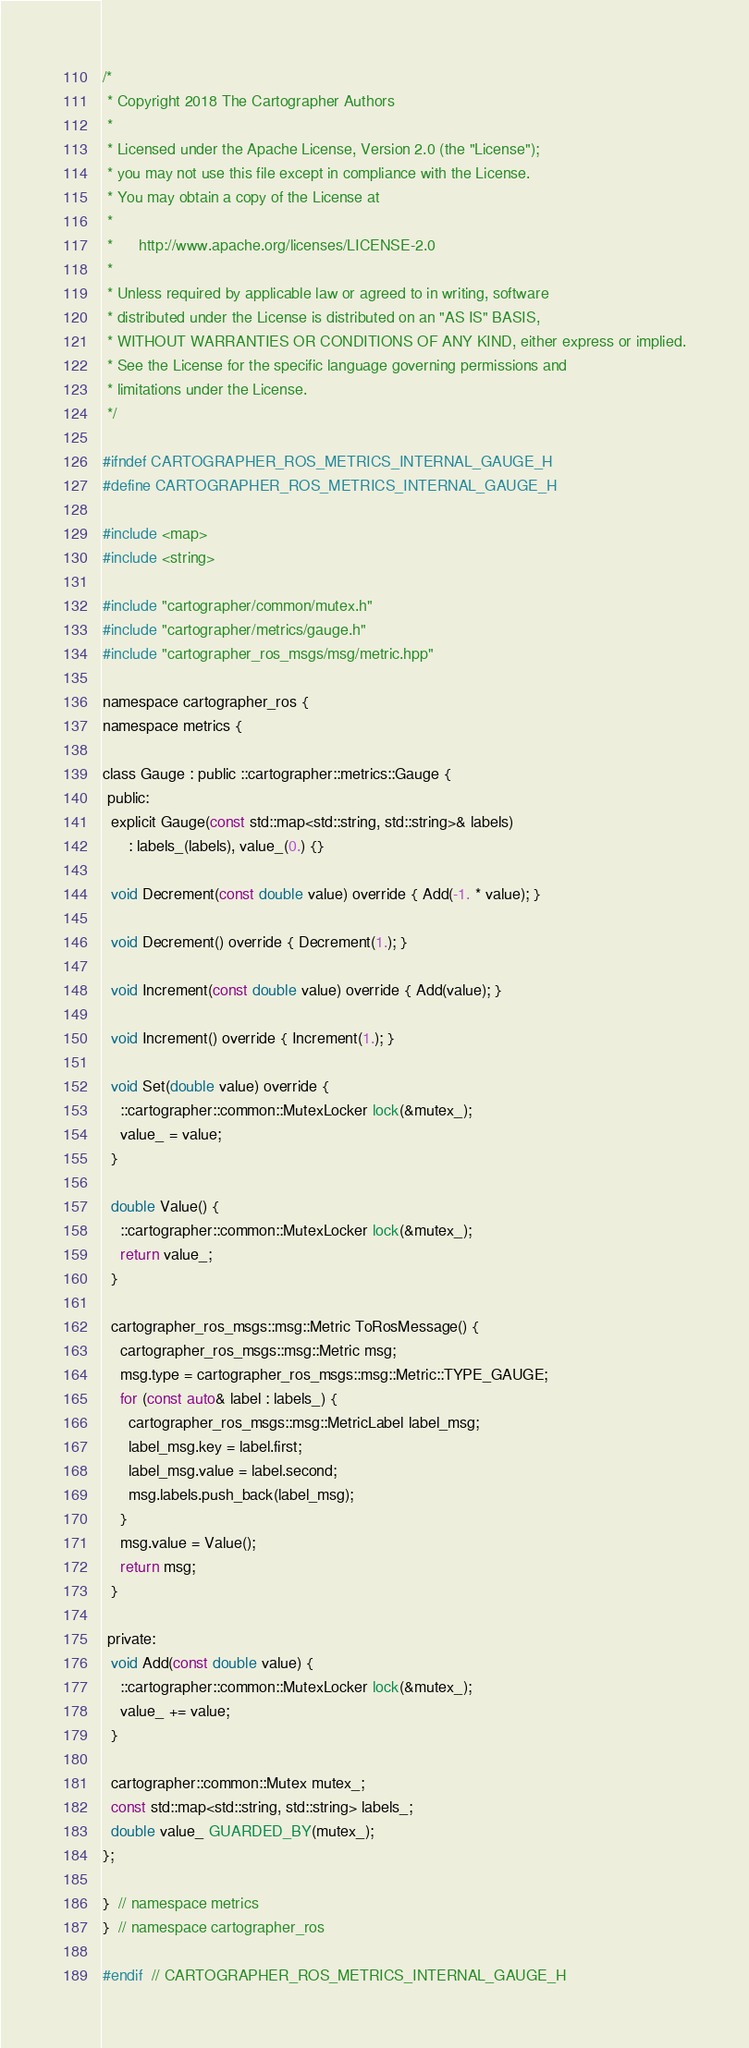Convert code to text. <code><loc_0><loc_0><loc_500><loc_500><_C_>/*
 * Copyright 2018 The Cartographer Authors
 *
 * Licensed under the Apache License, Version 2.0 (the "License");
 * you may not use this file except in compliance with the License.
 * You may obtain a copy of the License at
 *
 *      http://www.apache.org/licenses/LICENSE-2.0
 *
 * Unless required by applicable law or agreed to in writing, software
 * distributed under the License is distributed on an "AS IS" BASIS,
 * WITHOUT WARRANTIES OR CONDITIONS OF ANY KIND, either express or implied.
 * See the License for the specific language governing permissions and
 * limitations under the License.
 */

#ifndef CARTOGRAPHER_ROS_METRICS_INTERNAL_GAUGE_H
#define CARTOGRAPHER_ROS_METRICS_INTERNAL_GAUGE_H

#include <map>
#include <string>

#include "cartographer/common/mutex.h"
#include "cartographer/metrics/gauge.h"
#include "cartographer_ros_msgs/msg/metric.hpp"

namespace cartographer_ros {
namespace metrics {

class Gauge : public ::cartographer::metrics::Gauge {
 public:
  explicit Gauge(const std::map<std::string, std::string>& labels)
      : labels_(labels), value_(0.) {}

  void Decrement(const double value) override { Add(-1. * value); }

  void Decrement() override { Decrement(1.); }

  void Increment(const double value) override { Add(value); }

  void Increment() override { Increment(1.); }

  void Set(double value) override {
    ::cartographer::common::MutexLocker lock(&mutex_);
    value_ = value;
  }

  double Value() {
    ::cartographer::common::MutexLocker lock(&mutex_);
    return value_;
  }

  cartographer_ros_msgs::msg::Metric ToRosMessage() {
    cartographer_ros_msgs::msg::Metric msg;
    msg.type = cartographer_ros_msgs::msg::Metric::TYPE_GAUGE;
    for (const auto& label : labels_) {
      cartographer_ros_msgs::msg::MetricLabel label_msg;
      label_msg.key = label.first;
      label_msg.value = label.second;
      msg.labels.push_back(label_msg);
    }
    msg.value = Value();
    return msg;
  }

 private:
  void Add(const double value) {
    ::cartographer::common::MutexLocker lock(&mutex_);
    value_ += value;
  }

  cartographer::common::Mutex mutex_;
  const std::map<std::string, std::string> labels_;
  double value_ GUARDED_BY(mutex_);
};

}  // namespace metrics
}  // namespace cartographer_ros

#endif  // CARTOGRAPHER_ROS_METRICS_INTERNAL_GAUGE_H
</code> 